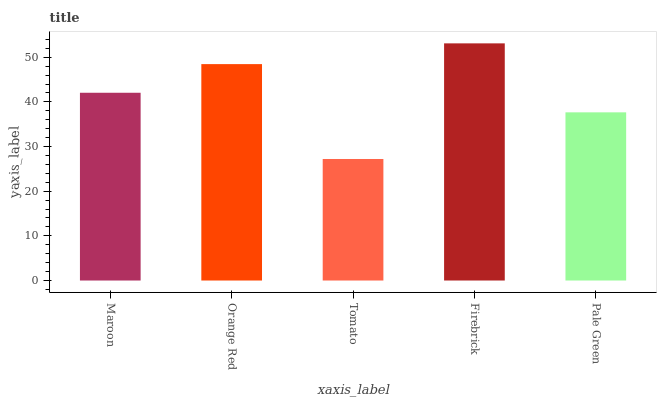Is Tomato the minimum?
Answer yes or no. Yes. Is Firebrick the maximum?
Answer yes or no. Yes. Is Orange Red the minimum?
Answer yes or no. No. Is Orange Red the maximum?
Answer yes or no. No. Is Orange Red greater than Maroon?
Answer yes or no. Yes. Is Maroon less than Orange Red?
Answer yes or no. Yes. Is Maroon greater than Orange Red?
Answer yes or no. No. Is Orange Red less than Maroon?
Answer yes or no. No. Is Maroon the high median?
Answer yes or no. Yes. Is Maroon the low median?
Answer yes or no. Yes. Is Firebrick the high median?
Answer yes or no. No. Is Pale Green the low median?
Answer yes or no. No. 